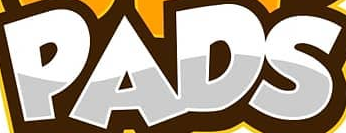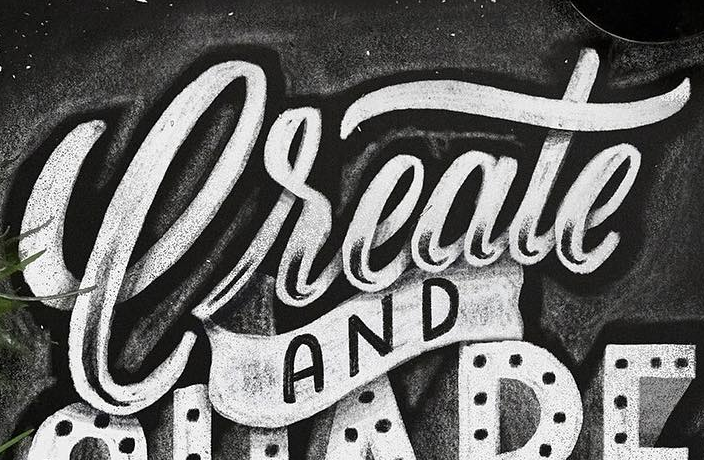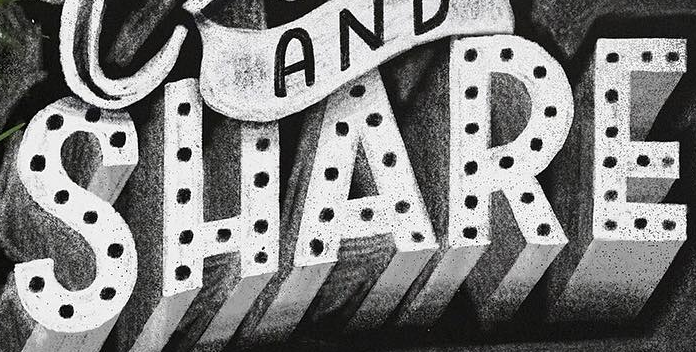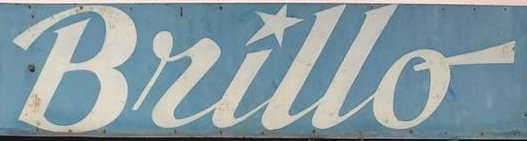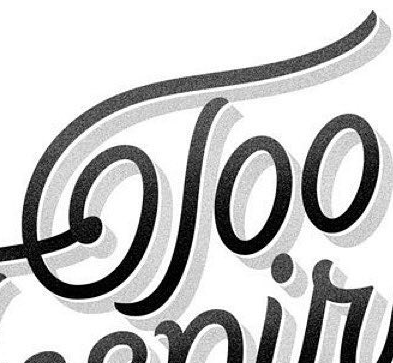Read the text from these images in sequence, separated by a semicolon. PADS; Create; SHARE; Bullo; Too 